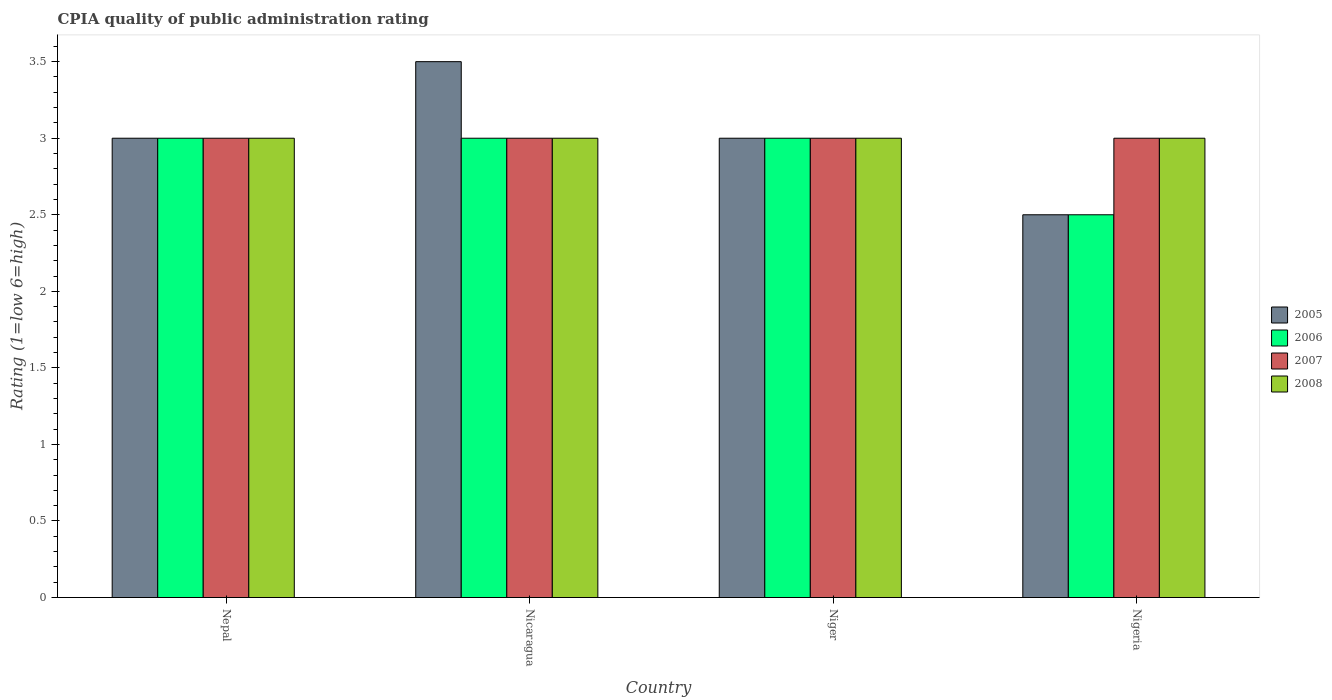How many bars are there on the 3rd tick from the left?
Provide a short and direct response. 4. What is the label of the 2nd group of bars from the left?
Ensure brevity in your answer.  Nicaragua. In how many cases, is the number of bars for a given country not equal to the number of legend labels?
Your answer should be compact. 0. Across all countries, what is the maximum CPIA rating in 2006?
Provide a succinct answer. 3. Across all countries, what is the minimum CPIA rating in 2006?
Make the answer very short. 2.5. In which country was the CPIA rating in 2007 maximum?
Ensure brevity in your answer.  Nepal. In which country was the CPIA rating in 2005 minimum?
Give a very brief answer. Nigeria. What is the total CPIA rating in 2006 in the graph?
Make the answer very short. 11.5. What is the difference between the CPIA rating in 2006 in Nigeria and the CPIA rating in 2008 in Niger?
Your response must be concise. -0.5. What is the average CPIA rating in 2005 per country?
Your response must be concise. 3. What is the difference between the CPIA rating of/in 2008 and CPIA rating of/in 2006 in Nepal?
Give a very brief answer. 0. In how many countries, is the CPIA rating in 2005 greater than 0.8?
Keep it short and to the point. 4. What is the ratio of the CPIA rating in 2008 in Niger to that in Nigeria?
Ensure brevity in your answer.  1. What is the difference between the highest and the second highest CPIA rating in 2005?
Your answer should be very brief. -0.5. In how many countries, is the CPIA rating in 2007 greater than the average CPIA rating in 2007 taken over all countries?
Your response must be concise. 0. Is it the case that in every country, the sum of the CPIA rating in 2006 and CPIA rating in 2007 is greater than the sum of CPIA rating in 2008 and CPIA rating in 2005?
Your answer should be very brief. No. What does the 4th bar from the right in Niger represents?
Your response must be concise. 2005. Are all the bars in the graph horizontal?
Provide a short and direct response. No. What is the difference between two consecutive major ticks on the Y-axis?
Give a very brief answer. 0.5. Are the values on the major ticks of Y-axis written in scientific E-notation?
Make the answer very short. No. Does the graph contain any zero values?
Provide a short and direct response. No. How many legend labels are there?
Give a very brief answer. 4. What is the title of the graph?
Provide a succinct answer. CPIA quality of public administration rating. Does "1995" appear as one of the legend labels in the graph?
Ensure brevity in your answer.  No. What is the label or title of the Y-axis?
Ensure brevity in your answer.  Rating (1=low 6=high). What is the Rating (1=low 6=high) of 2006 in Nepal?
Your answer should be very brief. 3. What is the Rating (1=low 6=high) of 2007 in Nepal?
Provide a short and direct response. 3. What is the Rating (1=low 6=high) in 2008 in Nicaragua?
Give a very brief answer. 3. What is the Rating (1=low 6=high) of 2005 in Niger?
Offer a terse response. 3. What is the Rating (1=low 6=high) of 2006 in Niger?
Ensure brevity in your answer.  3. What is the Rating (1=low 6=high) in 2007 in Niger?
Your response must be concise. 3. What is the Rating (1=low 6=high) in 2008 in Niger?
Offer a very short reply. 3. What is the Rating (1=low 6=high) in 2008 in Nigeria?
Make the answer very short. 3. Across all countries, what is the minimum Rating (1=low 6=high) in 2005?
Provide a succinct answer. 2.5. Across all countries, what is the minimum Rating (1=low 6=high) in 2007?
Your answer should be very brief. 3. Across all countries, what is the minimum Rating (1=low 6=high) of 2008?
Your response must be concise. 3. What is the total Rating (1=low 6=high) in 2005 in the graph?
Your response must be concise. 12. What is the total Rating (1=low 6=high) in 2006 in the graph?
Your response must be concise. 11.5. What is the total Rating (1=low 6=high) of 2007 in the graph?
Give a very brief answer. 12. What is the difference between the Rating (1=low 6=high) of 2005 in Nepal and that in Nicaragua?
Offer a very short reply. -0.5. What is the difference between the Rating (1=low 6=high) of 2006 in Nepal and that in Nicaragua?
Provide a succinct answer. 0. What is the difference between the Rating (1=low 6=high) in 2008 in Nepal and that in Nicaragua?
Ensure brevity in your answer.  0. What is the difference between the Rating (1=low 6=high) in 2005 in Nepal and that in Niger?
Make the answer very short. 0. What is the difference between the Rating (1=low 6=high) of 2007 in Nepal and that in Niger?
Offer a terse response. 0. What is the difference between the Rating (1=low 6=high) of 2005 in Nepal and that in Nigeria?
Offer a very short reply. 0.5. What is the difference between the Rating (1=low 6=high) in 2006 in Nepal and that in Nigeria?
Provide a succinct answer. 0.5. What is the difference between the Rating (1=low 6=high) of 2006 in Nicaragua and that in Niger?
Make the answer very short. 0. What is the difference between the Rating (1=low 6=high) of 2005 in Nicaragua and that in Nigeria?
Provide a short and direct response. 1. What is the difference between the Rating (1=low 6=high) of 2007 in Niger and that in Nigeria?
Provide a short and direct response. 0. What is the difference between the Rating (1=low 6=high) in 2008 in Niger and that in Nigeria?
Ensure brevity in your answer.  0. What is the difference between the Rating (1=low 6=high) of 2005 in Nepal and the Rating (1=low 6=high) of 2006 in Nicaragua?
Offer a terse response. 0. What is the difference between the Rating (1=low 6=high) of 2005 in Nepal and the Rating (1=low 6=high) of 2007 in Nicaragua?
Keep it short and to the point. 0. What is the difference between the Rating (1=low 6=high) in 2006 in Nepal and the Rating (1=low 6=high) in 2008 in Nicaragua?
Give a very brief answer. 0. What is the difference between the Rating (1=low 6=high) in 2007 in Nepal and the Rating (1=low 6=high) in 2008 in Nicaragua?
Your response must be concise. 0. What is the difference between the Rating (1=low 6=high) in 2005 in Nepal and the Rating (1=low 6=high) in 2007 in Niger?
Offer a terse response. 0. What is the difference between the Rating (1=low 6=high) in 2006 in Nepal and the Rating (1=low 6=high) in 2007 in Niger?
Your response must be concise. 0. What is the difference between the Rating (1=low 6=high) of 2006 in Nepal and the Rating (1=low 6=high) of 2008 in Niger?
Offer a very short reply. 0. What is the difference between the Rating (1=low 6=high) of 2005 in Nepal and the Rating (1=low 6=high) of 2006 in Nigeria?
Provide a succinct answer. 0.5. What is the difference between the Rating (1=low 6=high) of 2005 in Nepal and the Rating (1=low 6=high) of 2007 in Nigeria?
Your answer should be compact. 0. What is the difference between the Rating (1=low 6=high) of 2005 in Nepal and the Rating (1=low 6=high) of 2008 in Nigeria?
Make the answer very short. 0. What is the difference between the Rating (1=low 6=high) in 2006 in Nepal and the Rating (1=low 6=high) in 2008 in Nigeria?
Your answer should be compact. 0. What is the difference between the Rating (1=low 6=high) of 2007 in Nepal and the Rating (1=low 6=high) of 2008 in Nigeria?
Keep it short and to the point. 0. What is the difference between the Rating (1=low 6=high) of 2006 in Nicaragua and the Rating (1=low 6=high) of 2007 in Niger?
Give a very brief answer. 0. What is the difference between the Rating (1=low 6=high) in 2007 in Nicaragua and the Rating (1=low 6=high) in 2008 in Niger?
Provide a short and direct response. 0. What is the difference between the Rating (1=low 6=high) of 2006 in Nicaragua and the Rating (1=low 6=high) of 2008 in Nigeria?
Keep it short and to the point. 0. What is the difference between the Rating (1=low 6=high) of 2007 in Nicaragua and the Rating (1=low 6=high) of 2008 in Nigeria?
Provide a short and direct response. 0. What is the difference between the Rating (1=low 6=high) of 2005 in Niger and the Rating (1=low 6=high) of 2007 in Nigeria?
Your answer should be compact. 0. What is the average Rating (1=low 6=high) of 2005 per country?
Offer a very short reply. 3. What is the average Rating (1=low 6=high) in 2006 per country?
Your answer should be compact. 2.88. What is the average Rating (1=low 6=high) in 2007 per country?
Keep it short and to the point. 3. What is the difference between the Rating (1=low 6=high) of 2005 and Rating (1=low 6=high) of 2006 in Nepal?
Offer a terse response. 0. What is the difference between the Rating (1=low 6=high) in 2006 and Rating (1=low 6=high) in 2007 in Nepal?
Provide a short and direct response. 0. What is the difference between the Rating (1=low 6=high) in 2005 and Rating (1=low 6=high) in 2006 in Nicaragua?
Give a very brief answer. 0.5. What is the difference between the Rating (1=low 6=high) of 2005 and Rating (1=low 6=high) of 2008 in Nicaragua?
Your answer should be very brief. 0.5. What is the difference between the Rating (1=low 6=high) of 2006 and Rating (1=low 6=high) of 2007 in Nicaragua?
Keep it short and to the point. 0. What is the difference between the Rating (1=low 6=high) of 2007 and Rating (1=low 6=high) of 2008 in Nicaragua?
Provide a short and direct response. 0. What is the difference between the Rating (1=low 6=high) in 2005 and Rating (1=low 6=high) in 2008 in Niger?
Keep it short and to the point. 0. What is the difference between the Rating (1=low 6=high) of 2006 and Rating (1=low 6=high) of 2007 in Niger?
Provide a succinct answer. 0. What is the difference between the Rating (1=low 6=high) of 2005 and Rating (1=low 6=high) of 2006 in Nigeria?
Provide a succinct answer. 0. What is the difference between the Rating (1=low 6=high) of 2005 and Rating (1=low 6=high) of 2008 in Nigeria?
Your answer should be very brief. -0.5. What is the difference between the Rating (1=low 6=high) in 2006 and Rating (1=low 6=high) in 2007 in Nigeria?
Provide a succinct answer. -0.5. What is the ratio of the Rating (1=low 6=high) of 2005 in Nepal to that in Nicaragua?
Give a very brief answer. 0.86. What is the ratio of the Rating (1=low 6=high) in 2006 in Nepal to that in Nicaragua?
Your response must be concise. 1. What is the ratio of the Rating (1=low 6=high) in 2007 in Nepal to that in Nicaragua?
Offer a terse response. 1. What is the ratio of the Rating (1=low 6=high) in 2008 in Nepal to that in Nicaragua?
Provide a short and direct response. 1. What is the ratio of the Rating (1=low 6=high) of 2005 in Nepal to that in Nigeria?
Make the answer very short. 1.2. What is the ratio of the Rating (1=low 6=high) in 2007 in Nepal to that in Nigeria?
Offer a very short reply. 1. What is the ratio of the Rating (1=low 6=high) in 2006 in Nicaragua to that in Niger?
Your response must be concise. 1. What is the ratio of the Rating (1=low 6=high) in 2008 in Nicaragua to that in Niger?
Ensure brevity in your answer.  1. What is the ratio of the Rating (1=low 6=high) in 2008 in Nicaragua to that in Nigeria?
Offer a terse response. 1. What is the ratio of the Rating (1=low 6=high) of 2006 in Niger to that in Nigeria?
Your answer should be compact. 1.2. What is the ratio of the Rating (1=low 6=high) in 2008 in Niger to that in Nigeria?
Your answer should be very brief. 1. What is the difference between the highest and the second highest Rating (1=low 6=high) in 2008?
Ensure brevity in your answer.  0. What is the difference between the highest and the lowest Rating (1=low 6=high) in 2006?
Give a very brief answer. 0.5. 